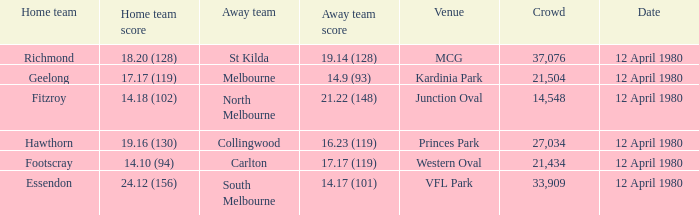At which location did fitzroy play their home games? Junction Oval. 